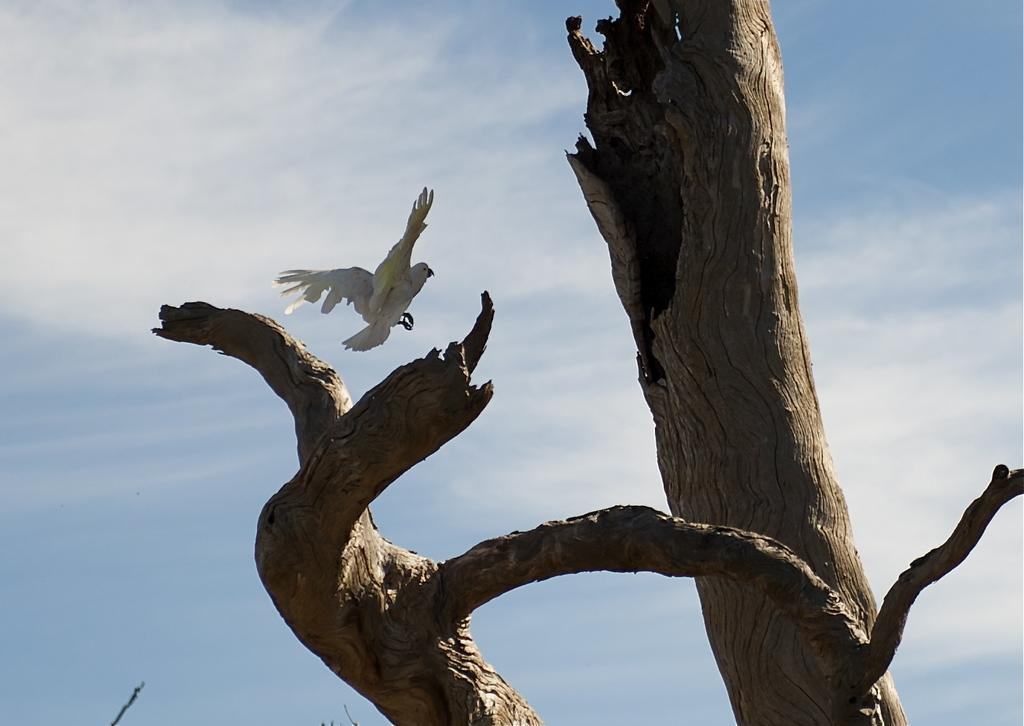What type of natural objects can be seen in the image? There are tree trunks in the image. What type of animal is present in the image? There is a bird in the image. What part of the natural environment is visible in the image? The sky is visible in the background of the image. How does the bird increase its wish in the image? There is no indication in the image that the bird is making a wish or that it can be increased. 